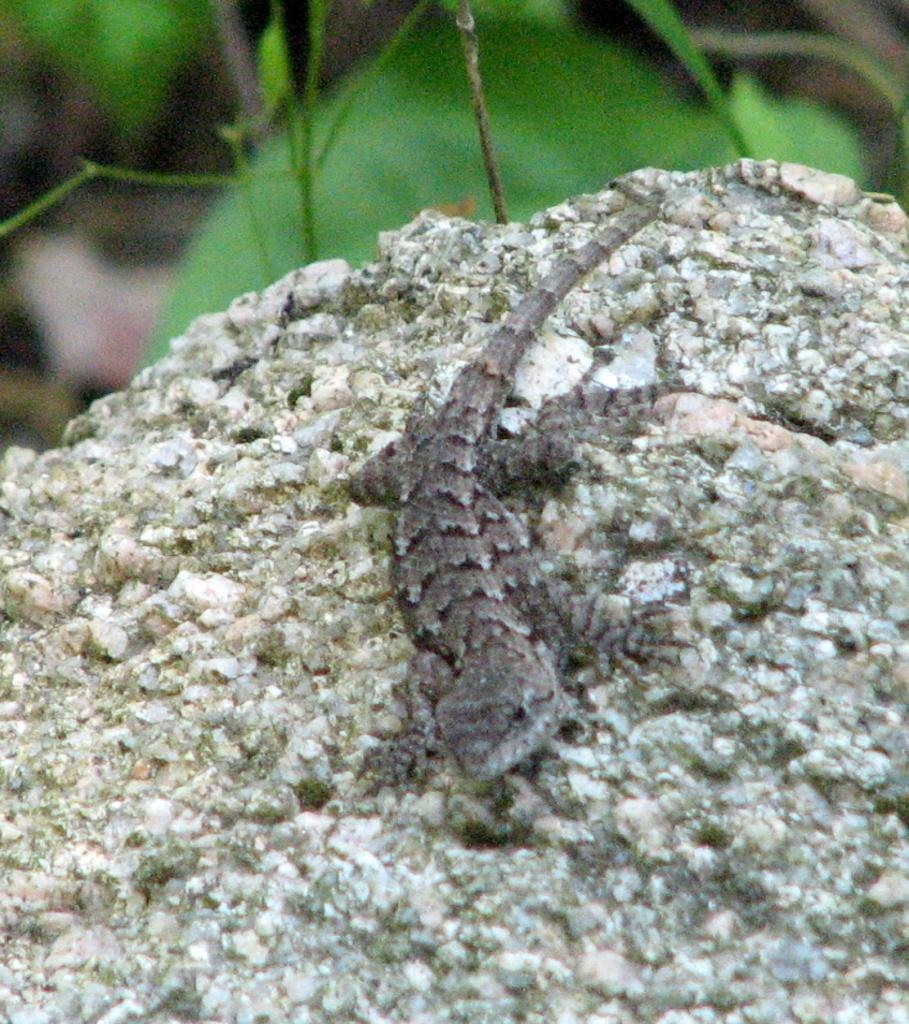What type of animal is in the image? There is a lizard in the image. What is the lizard situated on in the image? The lizard is on a rock surface. Can you describe the background of the image? The background of the image is blurred. What topic are the lizard and the rock discussing in the image? There is no indication in the image that the lizard and the rock are engaged in a discussion. Can you see a match nearby the lizard in the image? There is no match present in the image. 